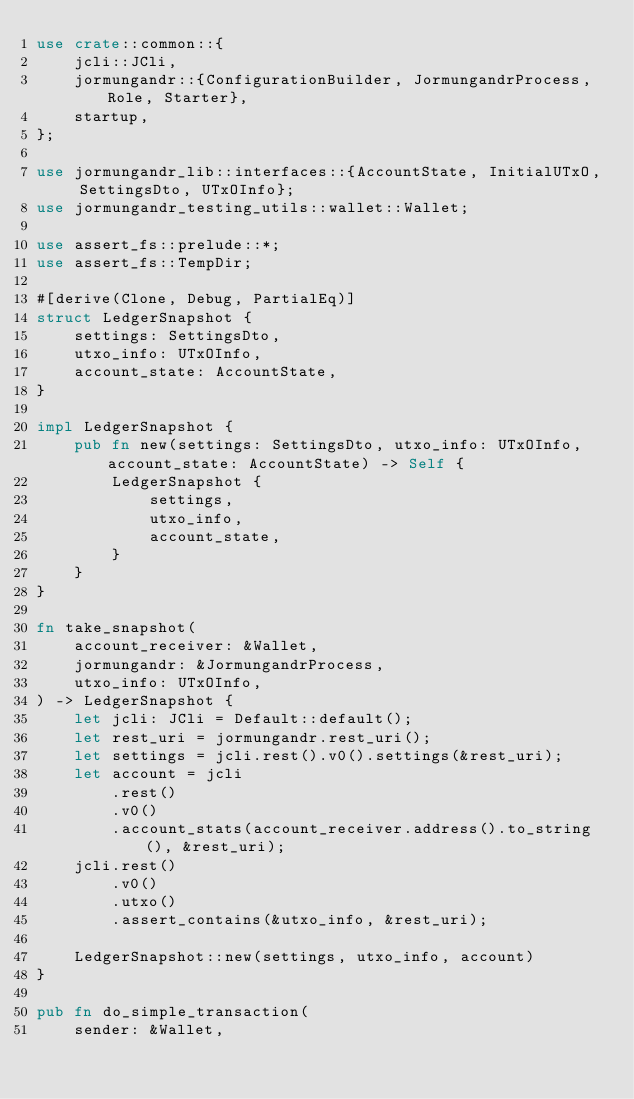<code> <loc_0><loc_0><loc_500><loc_500><_Rust_>use crate::common::{
    jcli::JCli,
    jormungandr::{ConfigurationBuilder, JormungandrProcess, Role, Starter},
    startup,
};

use jormungandr_lib::interfaces::{AccountState, InitialUTxO, SettingsDto, UTxOInfo};
use jormungandr_testing_utils::wallet::Wallet;

use assert_fs::prelude::*;
use assert_fs::TempDir;

#[derive(Clone, Debug, PartialEq)]
struct LedgerSnapshot {
    settings: SettingsDto,
    utxo_info: UTxOInfo,
    account_state: AccountState,
}

impl LedgerSnapshot {
    pub fn new(settings: SettingsDto, utxo_info: UTxOInfo, account_state: AccountState) -> Self {
        LedgerSnapshot {
            settings,
            utxo_info,
            account_state,
        }
    }
}

fn take_snapshot(
    account_receiver: &Wallet,
    jormungandr: &JormungandrProcess,
    utxo_info: UTxOInfo,
) -> LedgerSnapshot {
    let jcli: JCli = Default::default();
    let rest_uri = jormungandr.rest_uri();
    let settings = jcli.rest().v0().settings(&rest_uri);
    let account = jcli
        .rest()
        .v0()
        .account_stats(account_receiver.address().to_string(), &rest_uri);
    jcli.rest()
        .v0()
        .utxo()
        .assert_contains(&utxo_info, &rest_uri);

    LedgerSnapshot::new(settings, utxo_info, account)
}

pub fn do_simple_transaction(
    sender: &Wallet,</code> 